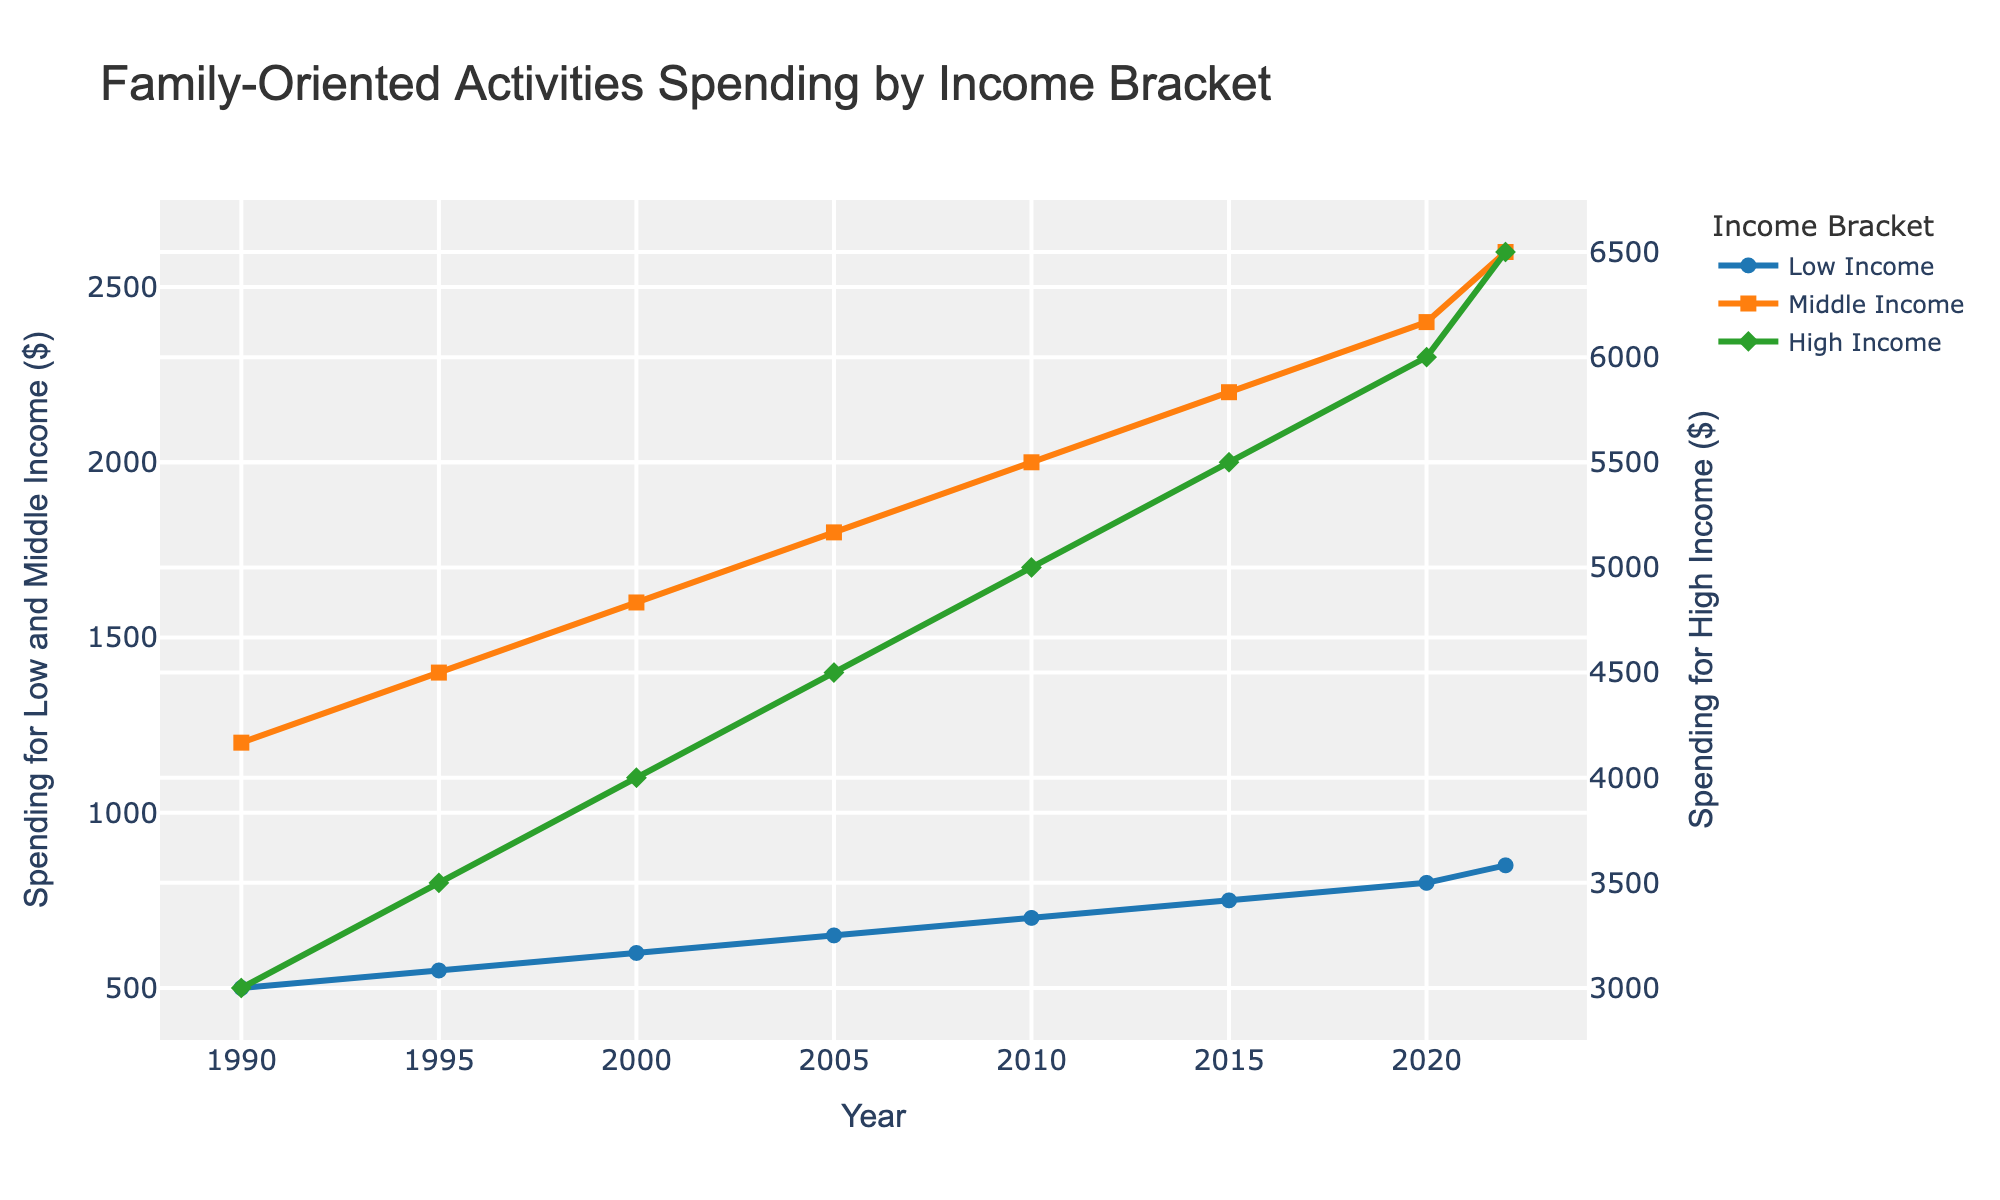What is the overall trend in spending on family-oriented activities by the High Income bracket from 1990 to 2022? The overall trend can be identified by observing the increasing values of spending from 1990 to 2022. From 1990 ($3000) to 2022 ($6500), the spending for the High Income bracket shows a steady increase every recorded year.
Answer: Steady increase Which income bracket had the highest spending in 2000? By comparing the y-values for each income bracket in the year 2000, we see that the High Income bracket spent $4000, which is the highest compared to Middle Income ($1600) and Low Income ($600).
Answer: High Income How much did the spending increase for the Middle Income bracket from 1990 to 2020? To find the increase, subtract the spending in 1990 ($1200) from the spending in 2020 ($2400). The difference is $2400 - $1200 = $1200.
Answer: $1200 What is the average spending for the Low Income bracket from 1990 to 2022? To find the average, sum the total spending from 1990 to 2022 ($500 + $550 + $600 + $650 + $700 + $750 + $800 + $850 = $5400) and divide it by the number of years (8). The average is $5400/8 = $675.
Answer: $675 In which year did the Middle Income bracket's spending surpass $2000? Observing the Middle Income spending values over the years, it surpasses $2000 in the year 2010 where it reached $2000 itself.
Answer: 2010 By how much did the High Income bracket's spending exceed the Low Income bracket's spending in 2022? Subtract the Low Income spending in 2022 ($850) from the High Income spending in 2022 ($6500). The difference is $6500 - $850 = $5650.
Answer: $5650 Across all years, which income bracket consistently experienced the least spending? By analyzing the plotted values across all years, the Low Income bracket consistently has the least spending each year compared to Middle and High Income brackets.
Answer: Low Income Which year showed the smallest increase in spending for the Middle Income bracket compared to its previous year? Comparing the differences year by year: (1990-1995: $200, 1995-2000: $200, 2000-2005: $200, 2005-2010: $200, 2010-2015: $200, 2015-2020: $200, 2020-2022: $200). All increases are equal, so any year can be given.
Answer: 1995 What is the spending difference between the High Income bracket and Middle Income bracket in the year 2005? Subtract the Middle Income spending ($1800) from the High Income spending ($4500) in 2005. The difference is $4500 - $1800 = $2700.
Answer: $2700 